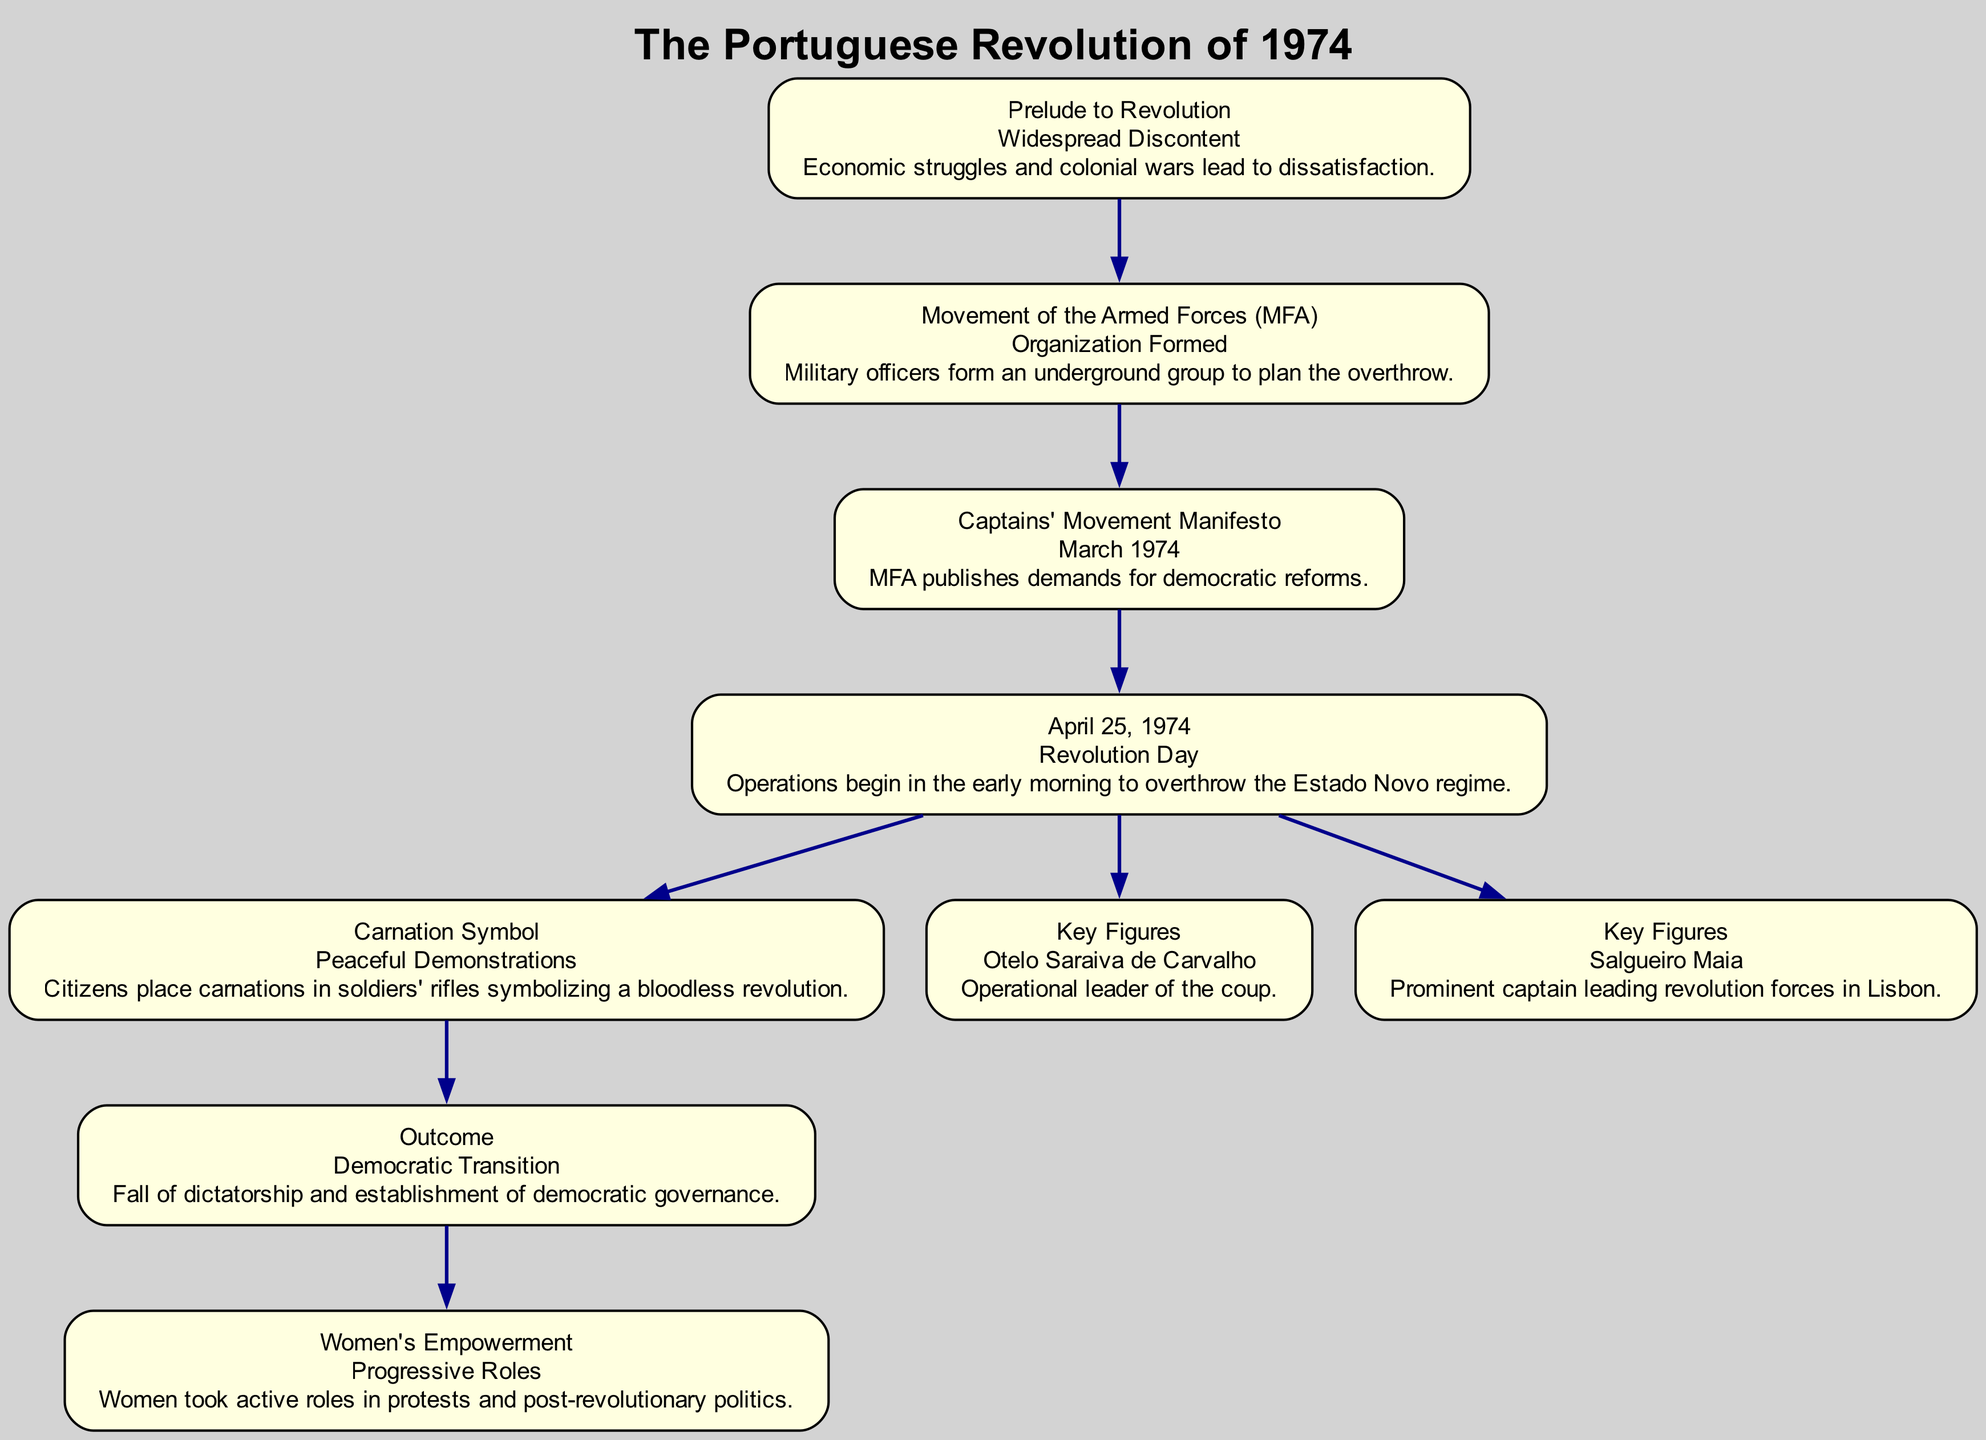What is the title of the first node in the diagram? The first node is labeled "Prelude to Revolution," as indicated at the top of the node in the rendered diagram.
Answer: Prelude to Revolution How many key figures are mentioned in the diagram? The diagram includes references to three key figures: Otelo Saraiva de Carvalho and Salgueiro Maia, along with a section for women's empowerment which highlights progressive roles. Thus, there are three mentions.
Answer: 3 What significant event is represented on April 25, 1974? The node corresponding to this date, titled "April 25, 1974," clearly states this is "Revolution Day," when operations to overthrow the Estado Novo regime began.
Answer: Revolution Day What symbolizes the peaceful nature of the Carnation Revolution? The diagram depicts the "Carnation Symbol" node which emphasizes that citizens placed carnations in soldiers' rifles, symbolizing a bloodless revolution.
Answer: Carnations Which event leads directly to the democratic transition? The diagram shows an edge from the "April 25, 1974" node to the "Outcome" node, which is titled "Democratic Transition," indicating that this event led to the establishment of democratic governance.
Answer: April 25, 1974 What role did women play after the revolution according to the diagram? The node titled "Women's Empowerment" indicates that women took active roles in protests and post-revolutionary politics, highlighting their progressive impact in this period.
Answer: Active roles in politics How does the "Movement of the Armed Forces" relate to the manifesto? The diagram illustrates an edge connecting the "Movement of the Armed Forces (MFA)" node to the "Captains' Movement Manifesto," indicating that the organization was formed to publish demands for democratic reforms.
Answer: They are connected through the manifesto What type of iconography is used to depict major protests in the diagram? The diagram includes a specific node titled "Carnation Symbol," which visually and symbolically represents the peaceful protests that characterized the Carnation Revolution.
Answer: Carnation Symbol 